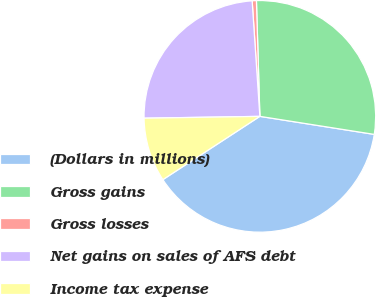Convert chart to OTSL. <chart><loc_0><loc_0><loc_500><loc_500><pie_chart><fcel>(Dollars in millions)<fcel>Gross gains<fcel>Gross losses<fcel>Net gains on sales of AFS debt<fcel>Income tax expense<nl><fcel>38.31%<fcel>27.96%<fcel>0.59%<fcel>24.19%<fcel>8.95%<nl></chart> 